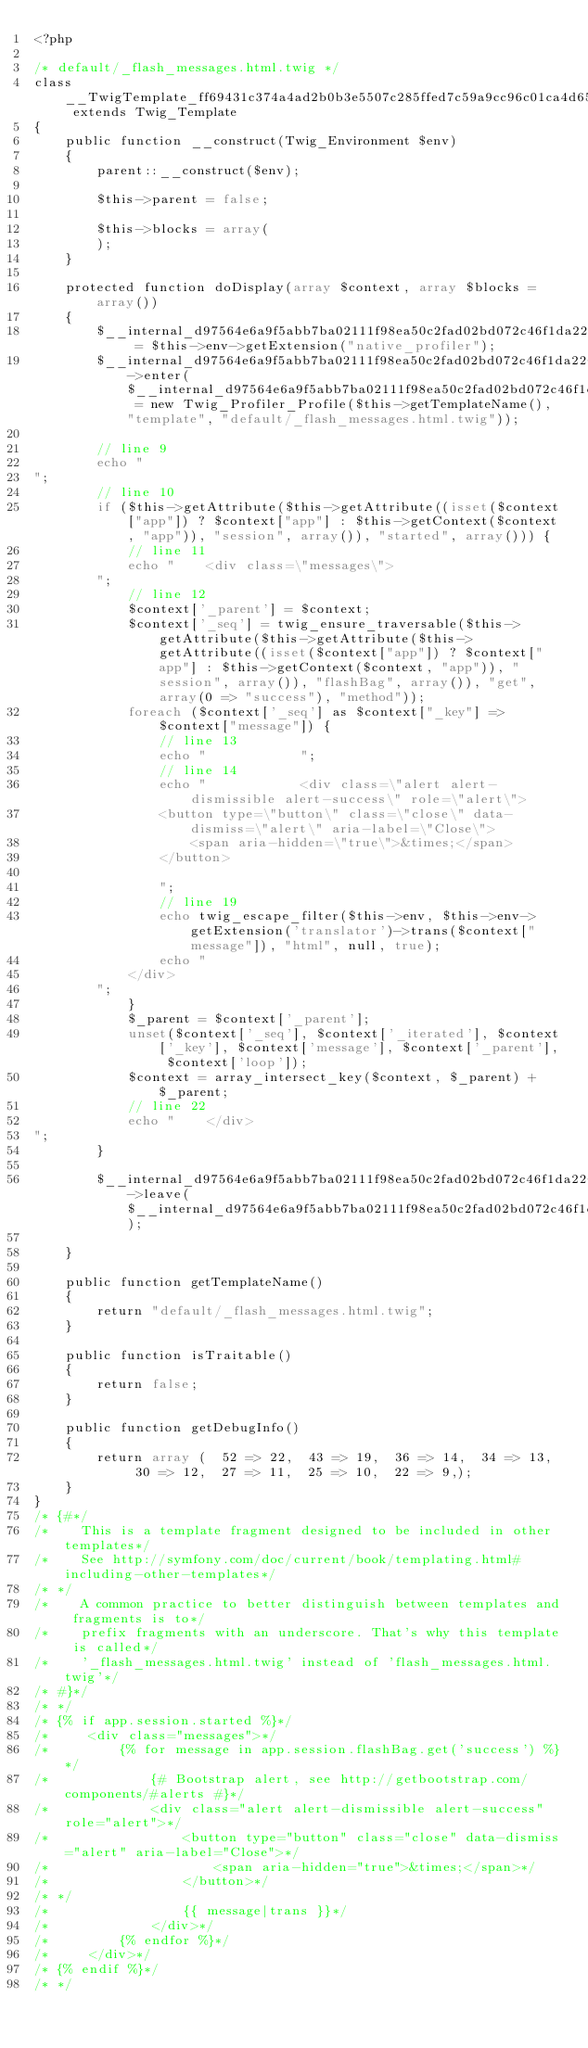Convert code to text. <code><loc_0><loc_0><loc_500><loc_500><_PHP_><?php

/* default/_flash_messages.html.twig */
class __TwigTemplate_ff69431c374a4ad2b0b3e5507c285ffed7c59a9cc96c01ca4d65d93fe5940914 extends Twig_Template
{
    public function __construct(Twig_Environment $env)
    {
        parent::__construct($env);

        $this->parent = false;

        $this->blocks = array(
        );
    }

    protected function doDisplay(array $context, array $blocks = array())
    {
        $__internal_d97564e6a9f5abb7ba02111f98ea50c2fad02bd072c46f1da2260d6c6bb8ad98 = $this->env->getExtension("native_profiler");
        $__internal_d97564e6a9f5abb7ba02111f98ea50c2fad02bd072c46f1da2260d6c6bb8ad98->enter($__internal_d97564e6a9f5abb7ba02111f98ea50c2fad02bd072c46f1da2260d6c6bb8ad98_prof = new Twig_Profiler_Profile($this->getTemplateName(), "template", "default/_flash_messages.html.twig"));

        // line 9
        echo "
";
        // line 10
        if ($this->getAttribute($this->getAttribute((isset($context["app"]) ? $context["app"] : $this->getContext($context, "app")), "session", array()), "started", array())) {
            // line 11
            echo "    <div class=\"messages\">
        ";
            // line 12
            $context['_parent'] = $context;
            $context['_seq'] = twig_ensure_traversable($this->getAttribute($this->getAttribute($this->getAttribute((isset($context["app"]) ? $context["app"] : $this->getContext($context, "app")), "session", array()), "flashBag", array()), "get", array(0 => "success"), "method"));
            foreach ($context['_seq'] as $context["_key"] => $context["message"]) {
                // line 13
                echo "            ";
                // line 14
                echo "            <div class=\"alert alert-dismissible alert-success\" role=\"alert\">
                <button type=\"button\" class=\"close\" data-dismiss=\"alert\" aria-label=\"Close\">
                    <span aria-hidden=\"true\">&times;</span>
                </button>

                ";
                // line 19
                echo twig_escape_filter($this->env, $this->env->getExtension('translator')->trans($context["message"]), "html", null, true);
                echo "
            </div>
        ";
            }
            $_parent = $context['_parent'];
            unset($context['_seq'], $context['_iterated'], $context['_key'], $context['message'], $context['_parent'], $context['loop']);
            $context = array_intersect_key($context, $_parent) + $_parent;
            // line 22
            echo "    </div>
";
        }
        
        $__internal_d97564e6a9f5abb7ba02111f98ea50c2fad02bd072c46f1da2260d6c6bb8ad98->leave($__internal_d97564e6a9f5abb7ba02111f98ea50c2fad02bd072c46f1da2260d6c6bb8ad98_prof);

    }

    public function getTemplateName()
    {
        return "default/_flash_messages.html.twig";
    }

    public function isTraitable()
    {
        return false;
    }

    public function getDebugInfo()
    {
        return array (  52 => 22,  43 => 19,  36 => 14,  34 => 13,  30 => 12,  27 => 11,  25 => 10,  22 => 9,);
    }
}
/* {#*/
/*    This is a template fragment designed to be included in other templates*/
/*    See http://symfony.com/doc/current/book/templating.html#including-other-templates*/
/* */
/*    A common practice to better distinguish between templates and fragments is to*/
/*    prefix fragments with an underscore. That's why this template is called*/
/*    '_flash_messages.html.twig' instead of 'flash_messages.html.twig'*/
/* #}*/
/* */
/* {% if app.session.started %}*/
/*     <div class="messages">*/
/*         {% for message in app.session.flashBag.get('success') %}*/
/*             {# Bootstrap alert, see http://getbootstrap.com/components/#alerts #}*/
/*             <div class="alert alert-dismissible alert-success" role="alert">*/
/*                 <button type="button" class="close" data-dismiss="alert" aria-label="Close">*/
/*                     <span aria-hidden="true">&times;</span>*/
/*                 </button>*/
/* */
/*                 {{ message|trans }}*/
/*             </div>*/
/*         {% endfor %}*/
/*     </div>*/
/* {% endif %}*/
/* */
</code> 